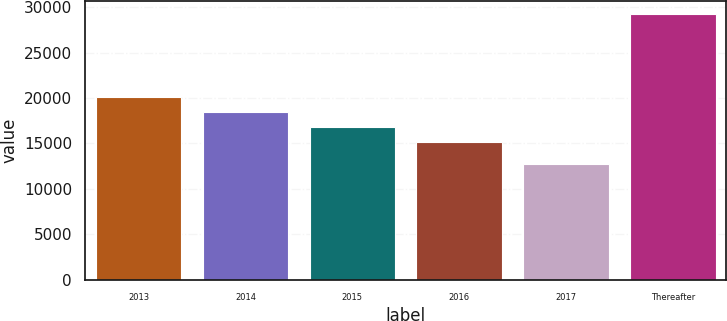<chart> <loc_0><loc_0><loc_500><loc_500><bar_chart><fcel>2013<fcel>2014<fcel>2015<fcel>2016<fcel>2017<fcel>Thereafter<nl><fcel>20086.8<fcel>18441.2<fcel>16795.6<fcel>15150<fcel>12787<fcel>29243<nl></chart> 